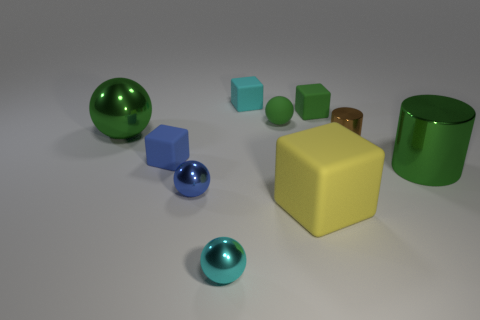The tiny cyan thing that is the same material as the yellow object is what shape?
Your answer should be very brief. Cube. Is the material of the green sphere on the left side of the cyan ball the same as the tiny green cube?
Provide a succinct answer. No. How many blue things are the same size as the cyan matte thing?
Keep it short and to the point. 2. Is the color of the small sphere right of the cyan sphere the same as the big metallic object to the left of the brown cylinder?
Your response must be concise. Yes. Are there any tiny matte things right of the tiny green rubber ball?
Your response must be concise. Yes. What is the color of the tiny object that is to the right of the big yellow thing and to the left of the tiny metal cylinder?
Provide a succinct answer. Green. Is there a tiny shiny object of the same color as the large rubber block?
Make the answer very short. No. Is the material of the small cyan thing that is behind the big green shiny cylinder the same as the big green object that is on the left side of the green cylinder?
Provide a succinct answer. No. What size is the green object to the left of the cyan rubber thing?
Your answer should be very brief. Large. What is the size of the yellow cube?
Your answer should be compact. Large. 